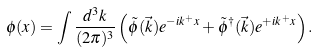<formula> <loc_0><loc_0><loc_500><loc_500>\phi ( x ) = \int \frac { d ^ { 3 } k } { ( 2 \pi ) ^ { 3 } } \left ( \tilde { \phi } ( \vec { k } ) e ^ { - i k ^ { + } x } + \tilde { \phi } ^ { \dagger } ( \vec { k } ) e ^ { + i k ^ { + } x } \right ) .</formula> 